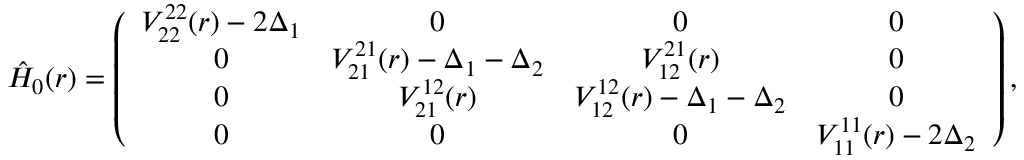Convert formula to latex. <formula><loc_0><loc_0><loc_500><loc_500>\hat { H } _ { 0 } ( r ) = \left ( \begin{array} { c c c c } { V _ { 2 2 } ^ { 2 2 } ( r ) - 2 \Delta _ { 1 } } & { 0 } & { 0 } & { 0 } \\ { 0 } & { V _ { 2 1 } ^ { 2 1 } ( r ) - \Delta _ { 1 } - \Delta _ { 2 } } & { V _ { 1 2 } ^ { 2 1 } ( r ) } & { 0 } \\ { 0 } & { V _ { 2 1 } ^ { 1 2 } ( r ) } & { V _ { 1 2 } ^ { 1 2 } ( r ) - \Delta _ { 1 } - \Delta _ { 2 } } & { 0 } \\ { 0 } & { 0 } & { 0 } & { V _ { 1 1 } ^ { 1 1 } ( r ) - 2 \Delta _ { 2 } } \end{array} \right ) ,</formula> 